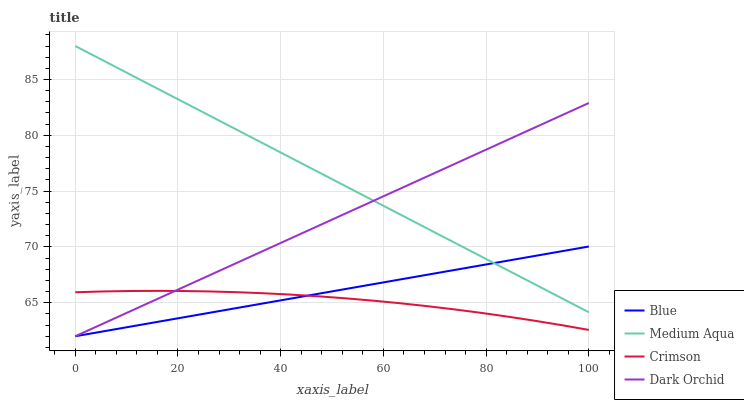Does Crimson have the minimum area under the curve?
Answer yes or no. Yes. Does Medium Aqua have the maximum area under the curve?
Answer yes or no. Yes. Does Medium Aqua have the minimum area under the curve?
Answer yes or no. No. Does Crimson have the maximum area under the curve?
Answer yes or no. No. Is Blue the smoothest?
Answer yes or no. Yes. Is Crimson the roughest?
Answer yes or no. Yes. Is Medium Aqua the smoothest?
Answer yes or no. No. Is Medium Aqua the roughest?
Answer yes or no. No. Does Blue have the lowest value?
Answer yes or no. Yes. Does Crimson have the lowest value?
Answer yes or no. No. Does Medium Aqua have the highest value?
Answer yes or no. Yes. Does Crimson have the highest value?
Answer yes or no. No. Is Crimson less than Medium Aqua?
Answer yes or no. Yes. Is Medium Aqua greater than Crimson?
Answer yes or no. Yes. Does Medium Aqua intersect Blue?
Answer yes or no. Yes. Is Medium Aqua less than Blue?
Answer yes or no. No. Is Medium Aqua greater than Blue?
Answer yes or no. No. Does Crimson intersect Medium Aqua?
Answer yes or no. No. 